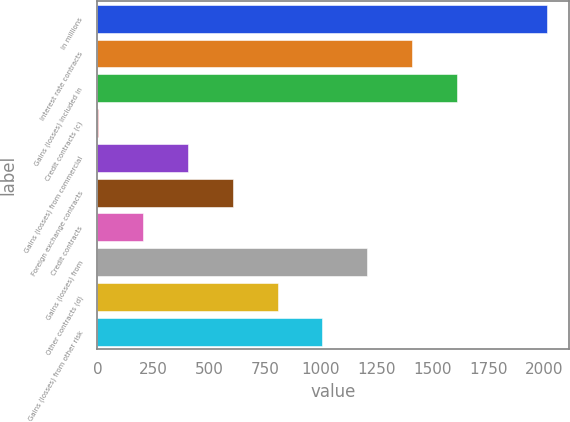Convert chart to OTSL. <chart><loc_0><loc_0><loc_500><loc_500><bar_chart><fcel>In millions<fcel>Interest rate contracts<fcel>Gains (losses) included in<fcel>Credit contracts (c)<fcel>Gains (losses) from commercial<fcel>Foreign exchange contracts<fcel>Credit contracts<fcel>Gains (losses) from<fcel>Other contracts (d)<fcel>Gains (losses) from other risk<nl><fcel>2012<fcel>1409.3<fcel>1610.2<fcel>3<fcel>404.8<fcel>605.7<fcel>203.9<fcel>1208.4<fcel>806.6<fcel>1007.5<nl></chart> 